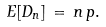Convert formula to latex. <formula><loc_0><loc_0><loc_500><loc_500>E [ D _ { n } ] \, = \, n \, p .</formula> 